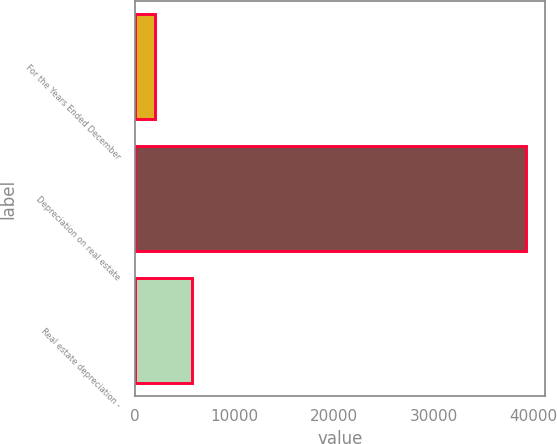Convert chart. <chart><loc_0><loc_0><loc_500><loc_500><bar_chart><fcel>For the Years Ended December<fcel>Depreciation on real estate<fcel>Real estate depreciation -<nl><fcel>2003<fcel>39216<fcel>5724.3<nl></chart> 